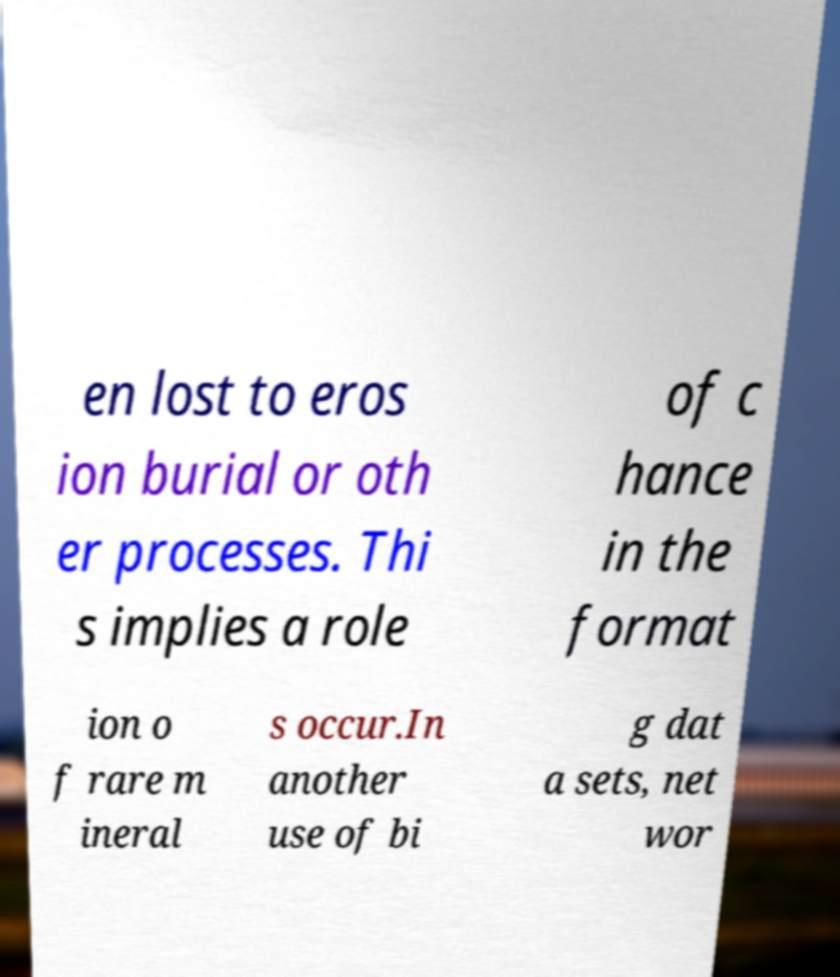What messages or text are displayed in this image? I need them in a readable, typed format. en lost to eros ion burial or oth er processes. Thi s implies a role of c hance in the format ion o f rare m ineral s occur.In another use of bi g dat a sets, net wor 